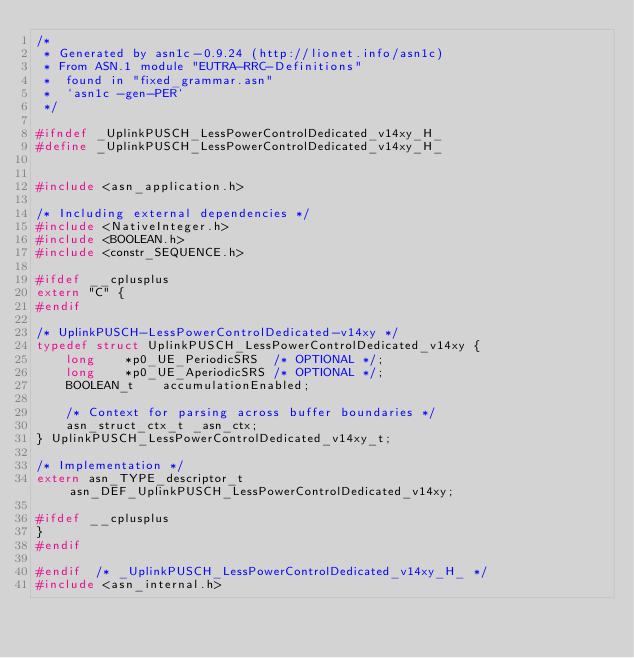Convert code to text. <code><loc_0><loc_0><loc_500><loc_500><_C_>/*
 * Generated by asn1c-0.9.24 (http://lionet.info/asn1c)
 * From ASN.1 module "EUTRA-RRC-Definitions"
 * 	found in "fixed_grammar.asn"
 * 	`asn1c -gen-PER`
 */

#ifndef	_UplinkPUSCH_LessPowerControlDedicated_v14xy_H_
#define	_UplinkPUSCH_LessPowerControlDedicated_v14xy_H_


#include <asn_application.h>

/* Including external dependencies */
#include <NativeInteger.h>
#include <BOOLEAN.h>
#include <constr_SEQUENCE.h>

#ifdef __cplusplus
extern "C" {
#endif

/* UplinkPUSCH-LessPowerControlDedicated-v14xy */
typedef struct UplinkPUSCH_LessPowerControlDedicated_v14xy {
	long	*p0_UE_PeriodicSRS	/* OPTIONAL */;
	long	*p0_UE_AperiodicSRS	/* OPTIONAL */;
	BOOLEAN_t	 accumulationEnabled;
	
	/* Context for parsing across buffer boundaries */
	asn_struct_ctx_t _asn_ctx;
} UplinkPUSCH_LessPowerControlDedicated_v14xy_t;

/* Implementation */
extern asn_TYPE_descriptor_t asn_DEF_UplinkPUSCH_LessPowerControlDedicated_v14xy;

#ifdef __cplusplus
}
#endif

#endif	/* _UplinkPUSCH_LessPowerControlDedicated_v14xy_H_ */
#include <asn_internal.h>
</code> 